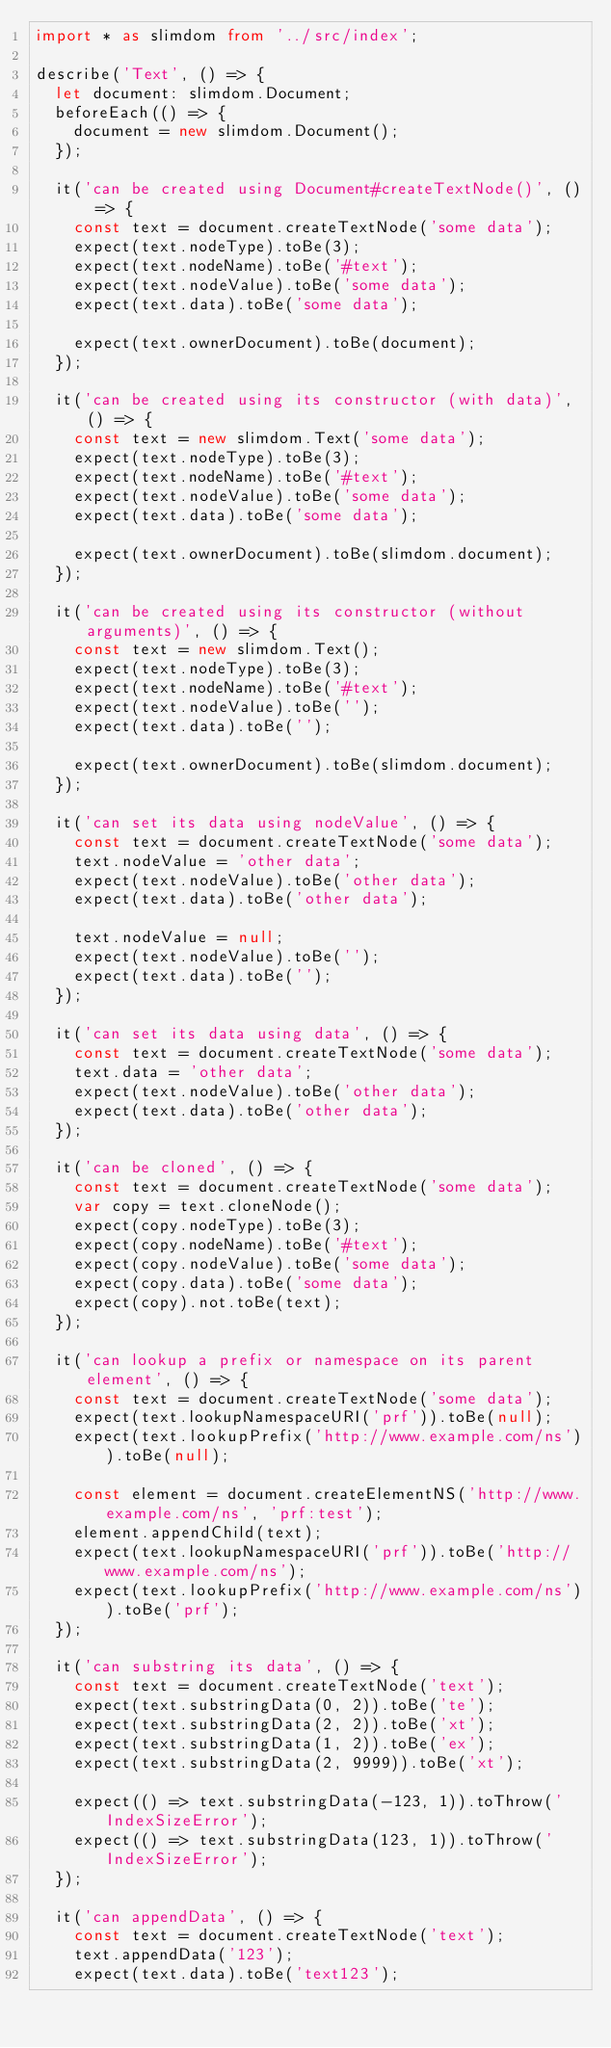<code> <loc_0><loc_0><loc_500><loc_500><_TypeScript_>import * as slimdom from '../src/index';

describe('Text', () => {
	let document: slimdom.Document;
	beforeEach(() => {
		document = new slimdom.Document();
	});

	it('can be created using Document#createTextNode()', () => {
		const text = document.createTextNode('some data');
		expect(text.nodeType).toBe(3);
		expect(text.nodeName).toBe('#text');
		expect(text.nodeValue).toBe('some data');
		expect(text.data).toBe('some data');

		expect(text.ownerDocument).toBe(document);
	});

	it('can be created using its constructor (with data)', () => {
		const text = new slimdom.Text('some data');
		expect(text.nodeType).toBe(3);
		expect(text.nodeName).toBe('#text');
		expect(text.nodeValue).toBe('some data');
		expect(text.data).toBe('some data');

		expect(text.ownerDocument).toBe(slimdom.document);
	});

	it('can be created using its constructor (without arguments)', () => {
		const text = new slimdom.Text();
		expect(text.nodeType).toBe(3);
		expect(text.nodeName).toBe('#text');
		expect(text.nodeValue).toBe('');
		expect(text.data).toBe('');

		expect(text.ownerDocument).toBe(slimdom.document);
	});

	it('can set its data using nodeValue', () => {
		const text = document.createTextNode('some data');
		text.nodeValue = 'other data';
		expect(text.nodeValue).toBe('other data');
		expect(text.data).toBe('other data');

		text.nodeValue = null;
		expect(text.nodeValue).toBe('');
		expect(text.data).toBe('');
	});

	it('can set its data using data', () => {
		const text = document.createTextNode('some data');
		text.data = 'other data';
		expect(text.nodeValue).toBe('other data');
		expect(text.data).toBe('other data');
	});

	it('can be cloned', () => {
		const text = document.createTextNode('some data');
		var copy = text.cloneNode();
		expect(copy.nodeType).toBe(3);
		expect(copy.nodeName).toBe('#text');
		expect(copy.nodeValue).toBe('some data');
		expect(copy.data).toBe('some data');
		expect(copy).not.toBe(text);
	});

	it('can lookup a prefix or namespace on its parent element', () => {
		const text = document.createTextNode('some data');
		expect(text.lookupNamespaceURI('prf')).toBe(null);
		expect(text.lookupPrefix('http://www.example.com/ns')).toBe(null);

		const element = document.createElementNS('http://www.example.com/ns', 'prf:test');
		element.appendChild(text);
		expect(text.lookupNamespaceURI('prf')).toBe('http://www.example.com/ns');
		expect(text.lookupPrefix('http://www.example.com/ns')).toBe('prf');
	});

	it('can substring its data', () => {
		const text = document.createTextNode('text');
		expect(text.substringData(0, 2)).toBe('te');
		expect(text.substringData(2, 2)).toBe('xt');
		expect(text.substringData(1, 2)).toBe('ex');
		expect(text.substringData(2, 9999)).toBe('xt');

		expect(() => text.substringData(-123, 1)).toThrow('IndexSizeError');
		expect(() => text.substringData(123, 1)).toThrow('IndexSizeError');
	});

	it('can appendData', () => {
		const text = document.createTextNode('text');
		text.appendData('123');
		expect(text.data).toBe('text123');</code> 